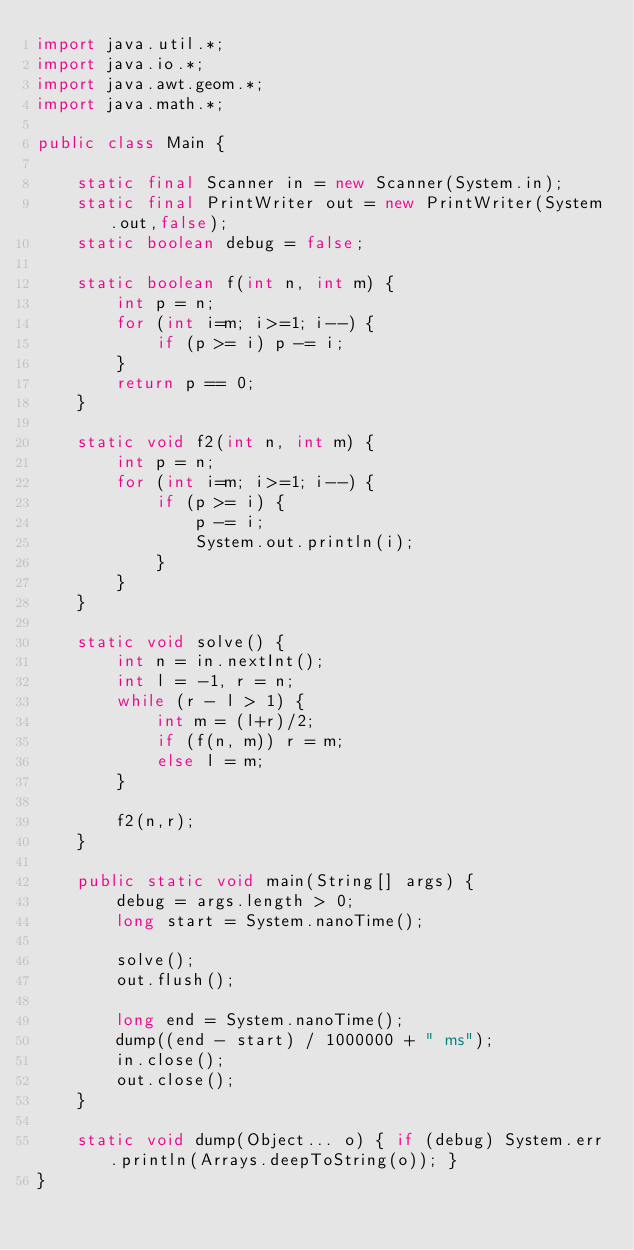<code> <loc_0><loc_0><loc_500><loc_500><_Java_>import java.util.*;
import java.io.*;
import java.awt.geom.*;
import java.math.*;

public class Main {

	static final Scanner in = new Scanner(System.in);
	static final PrintWriter out = new PrintWriter(System.out,false);
	static boolean debug = false;

	static boolean f(int n, int m) {
		int p = n;
		for (int i=m; i>=1; i--) {
			if (p >= i) p -= i;
		}
		return p == 0;
	}

	static void f2(int n, int m) {
		int p = n;
		for (int i=m; i>=1; i--) {
			if (p >= i) {
				p -= i;
				System.out.println(i);
			}
		}
	}

	static void solve() {
		int n = in.nextInt();
		int l = -1, r = n;
		while (r - l > 1) {
			int m = (l+r)/2;
			if (f(n, m)) r = m;
			else l = m;
		}

		f2(n,r);
	}

	public static void main(String[] args) {
		debug = args.length > 0;
		long start = System.nanoTime();

		solve();
		out.flush();

		long end = System.nanoTime();
		dump((end - start) / 1000000 + " ms");
		in.close();
		out.close();
	}

	static void dump(Object... o) { if (debug) System.err.println(Arrays.deepToString(o)); }
}</code> 